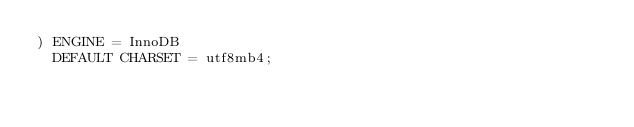<code> <loc_0><loc_0><loc_500><loc_500><_SQL_>) ENGINE = InnoDB
  DEFAULT CHARSET = utf8mb4;
</code> 